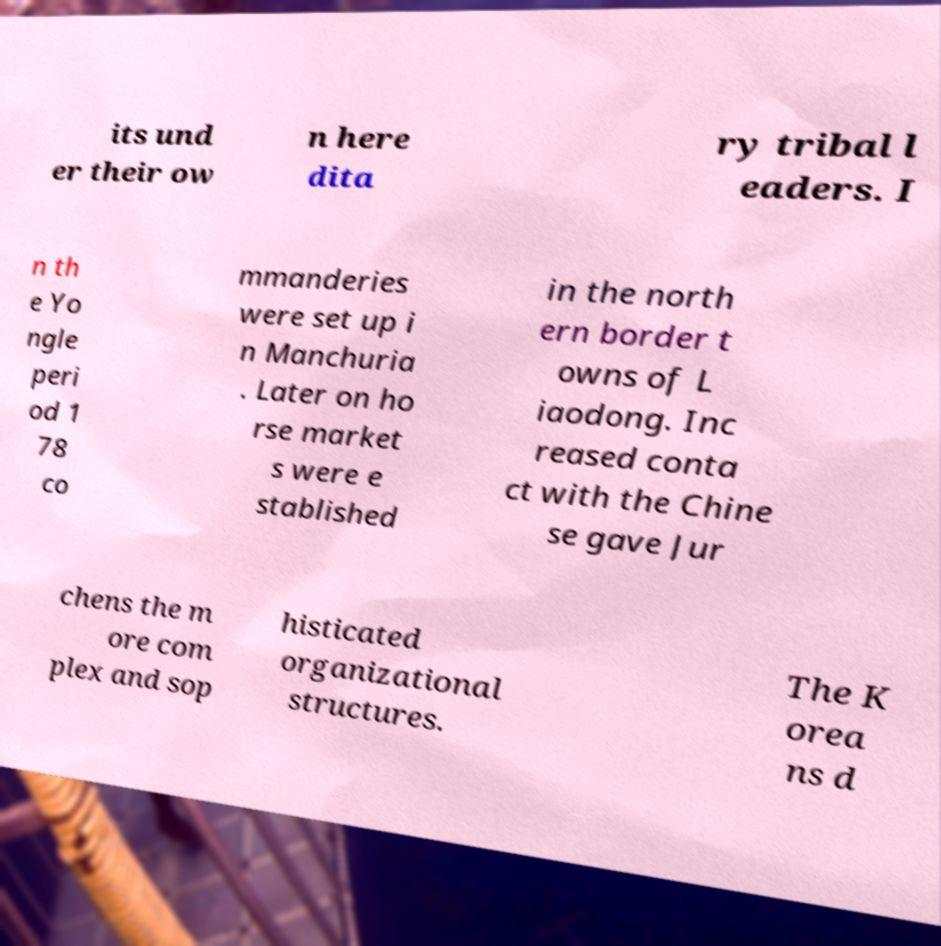What messages or text are displayed in this image? I need them in a readable, typed format. its und er their ow n here dita ry tribal l eaders. I n th e Yo ngle peri od 1 78 co mmanderies were set up i n Manchuria . Later on ho rse market s were e stablished in the north ern border t owns of L iaodong. Inc reased conta ct with the Chine se gave Jur chens the m ore com plex and sop histicated organizational structures. The K orea ns d 